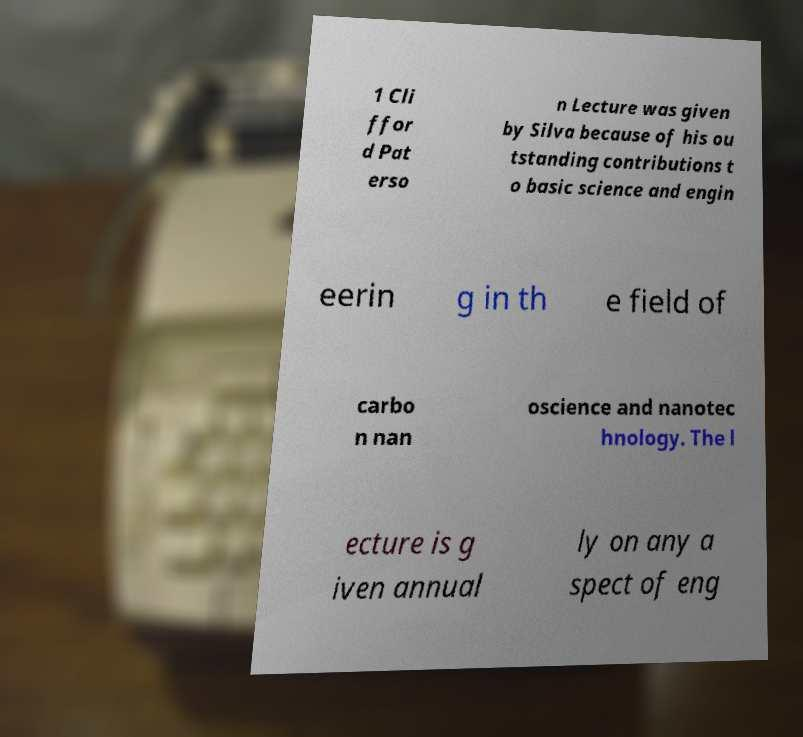Could you extract and type out the text from this image? 1 Cli ffor d Pat erso n Lecture was given by Silva because of his ou tstanding contributions t o basic science and engin eerin g in th e field of carbo n nan oscience and nanotec hnology. The l ecture is g iven annual ly on any a spect of eng 